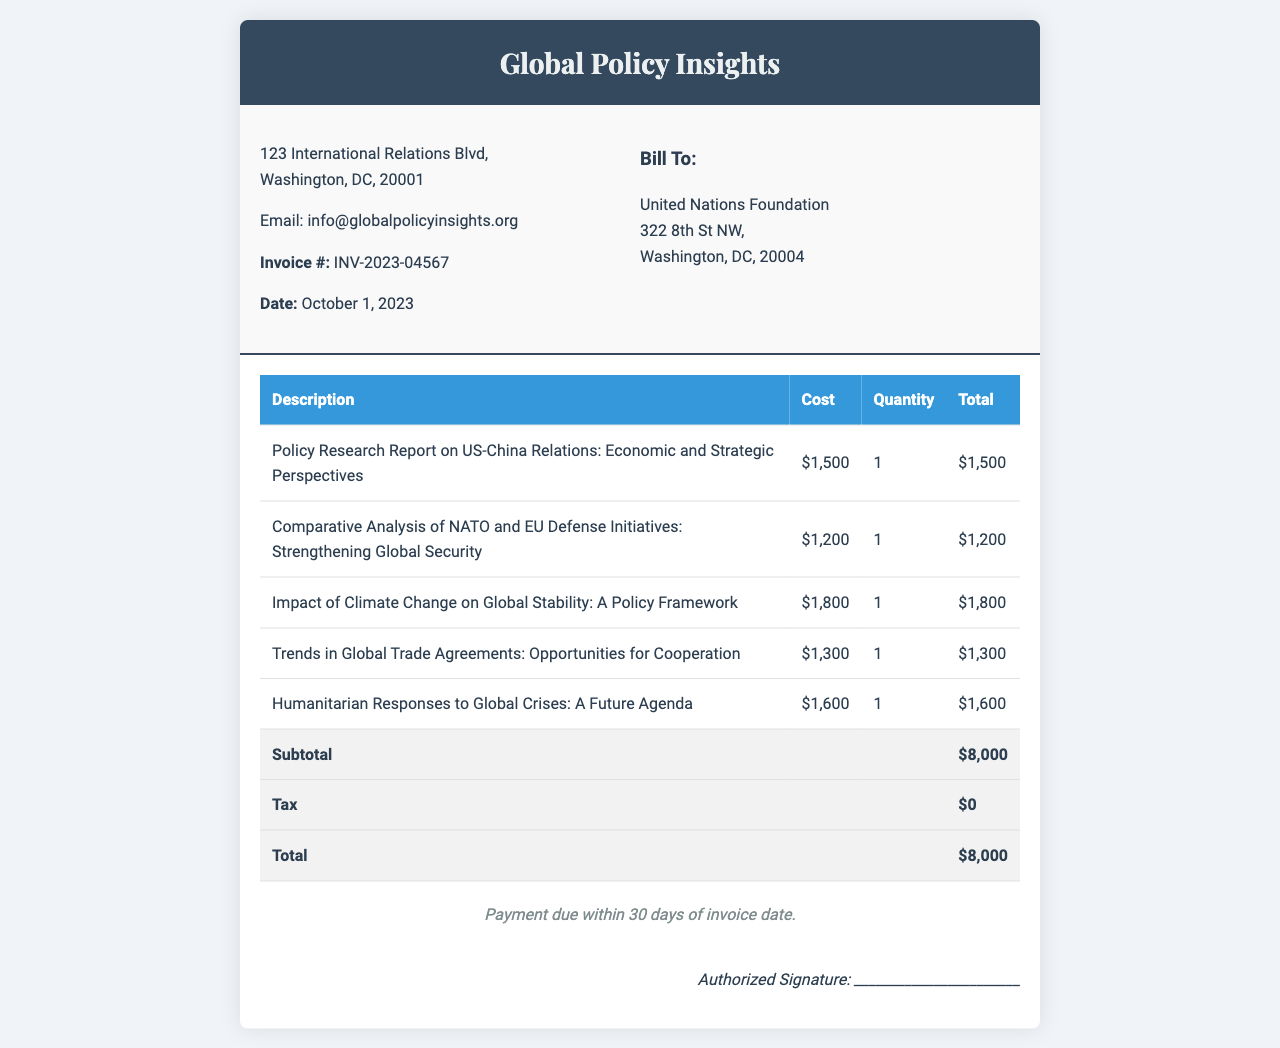What is the invoice number? The invoice number is listed under the company details section in the document.
Answer: INV-2023-04567 What is the date of the invoice? The invoice date is included in the details section along with the invoice number.
Answer: October 1, 2023 Who is the client for this invoice? The "Bill To" section outlines the client details in the document.
Answer: United Nations Foundation What is the total amount due on this invoice? The total is mentioned at the end of the table summarizing all costs in the document.
Answer: $8,000 How many reports are itemized in the invoice? The number of reports can be counted from the rows listed in the table.
Answer: 5 What is the cost of the report on US-China relations? The specific cost for the report is listed in the corresponding row of the table.
Answer: $1,500 What is the subtotal before tax? The subtotal is provided as a specific item in the invoice summary.
Answer: $8,000 When is the payment due? The payment terms are stated at the end of the invoice body.
Answer: Within 30 days What email address is provided for Global Policy Insights? The email address is included in the company details section of the invoice.
Answer: info@globalpolicyinsights.org 